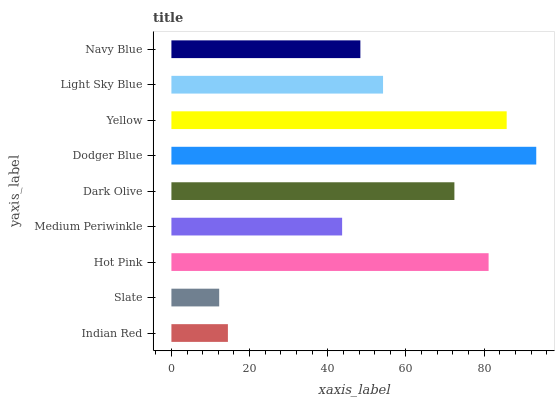Is Slate the minimum?
Answer yes or no. Yes. Is Dodger Blue the maximum?
Answer yes or no. Yes. Is Hot Pink the minimum?
Answer yes or no. No. Is Hot Pink the maximum?
Answer yes or no. No. Is Hot Pink greater than Slate?
Answer yes or no. Yes. Is Slate less than Hot Pink?
Answer yes or no. Yes. Is Slate greater than Hot Pink?
Answer yes or no. No. Is Hot Pink less than Slate?
Answer yes or no. No. Is Light Sky Blue the high median?
Answer yes or no. Yes. Is Light Sky Blue the low median?
Answer yes or no. Yes. Is Yellow the high median?
Answer yes or no. No. Is Indian Red the low median?
Answer yes or no. No. 